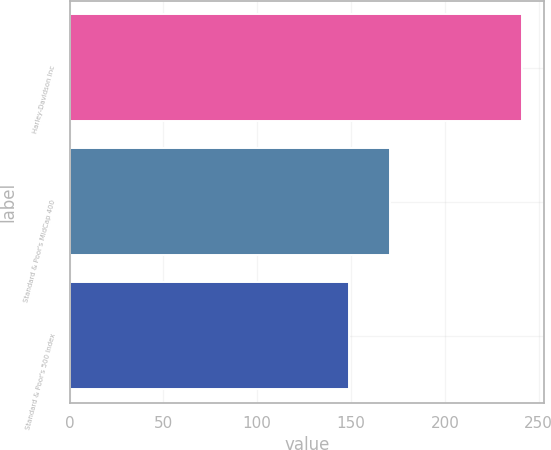<chart> <loc_0><loc_0><loc_500><loc_500><bar_chart><fcel>Harley-Davidson Inc<fcel>Standard & Poor's MidCap 400<fcel>Standard & Poor's 500 Index<nl><fcel>241<fcel>171<fcel>149<nl></chart> 